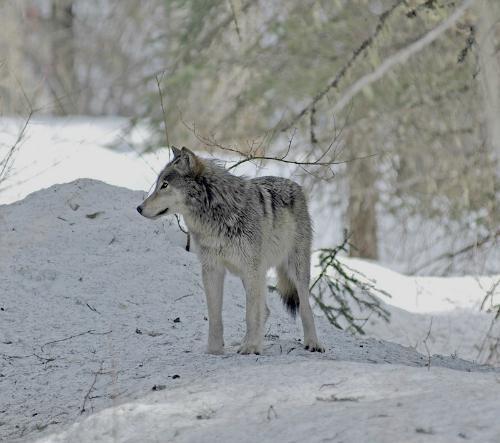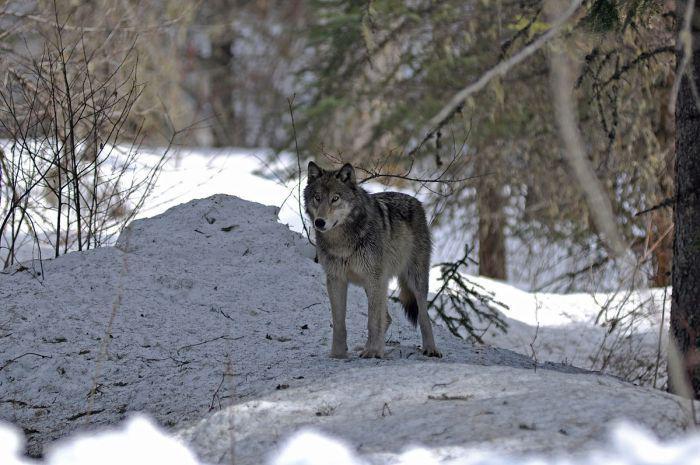The first image is the image on the left, the second image is the image on the right. Given the left and right images, does the statement "At least one of the wolves is visibly standing on snow." hold true? Answer yes or no. Yes. 